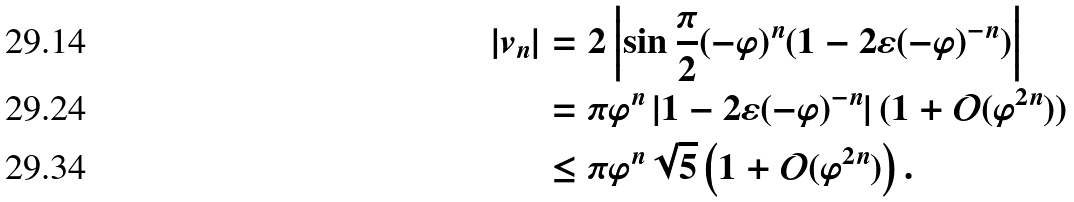Convert formula to latex. <formula><loc_0><loc_0><loc_500><loc_500>| v _ { n } | & = 2 \left | \sin \frac { \pi } { 2 } ( - \varphi ) ^ { n } ( 1 - 2 \varepsilon ( - \varphi ) ^ { - n } ) \right | \\ & = \pi \varphi ^ { n } \, | 1 - 2 \varepsilon ( - \varphi ) ^ { - n } | \, ( 1 + \mathcal { O } ( \varphi ^ { 2 n } ) ) \\ & \leq \pi \varphi ^ { n } \sqrt { 5 } \left ( 1 + \mathcal { O } ( \varphi ^ { 2 n } ) \right ) .</formula> 